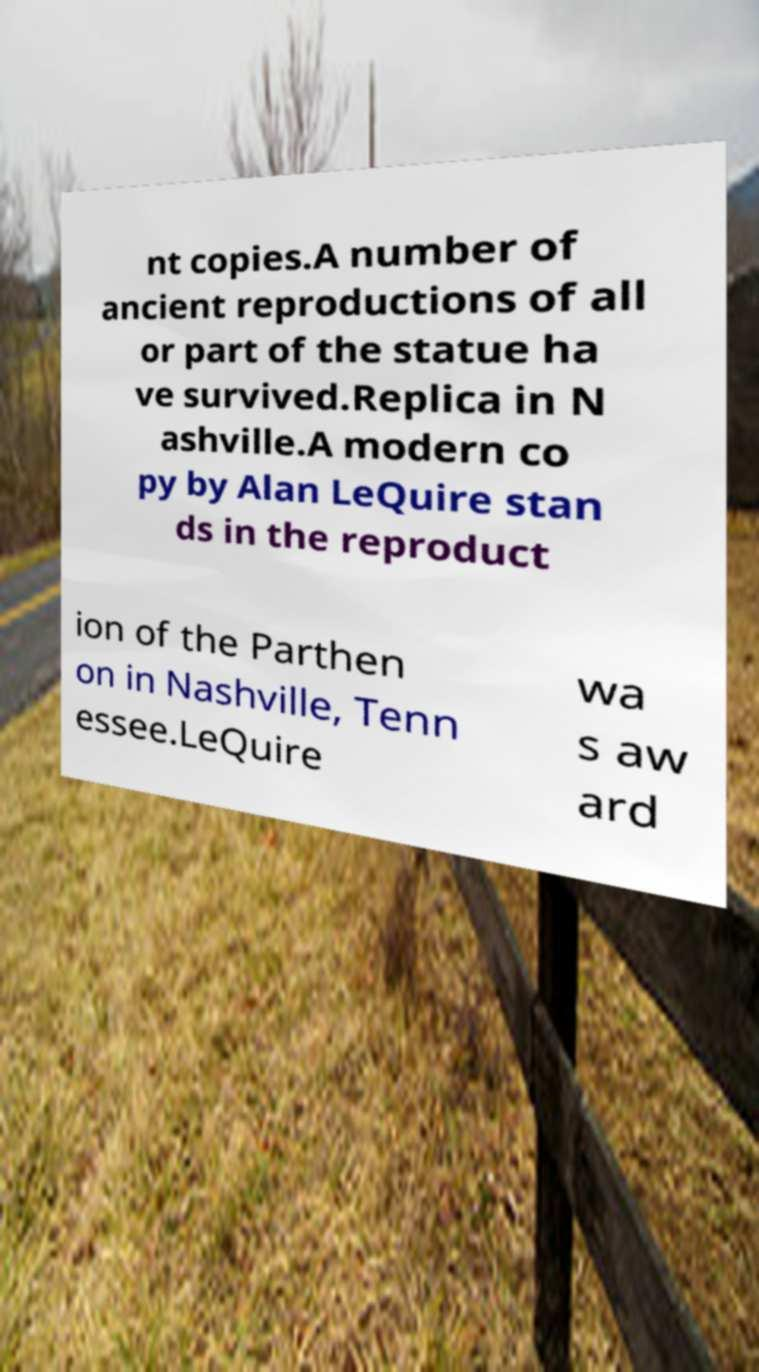Can you accurately transcribe the text from the provided image for me? nt copies.A number of ancient reproductions of all or part of the statue ha ve survived.Replica in N ashville.A modern co py by Alan LeQuire stan ds in the reproduct ion of the Parthen on in Nashville, Tenn essee.LeQuire wa s aw ard 